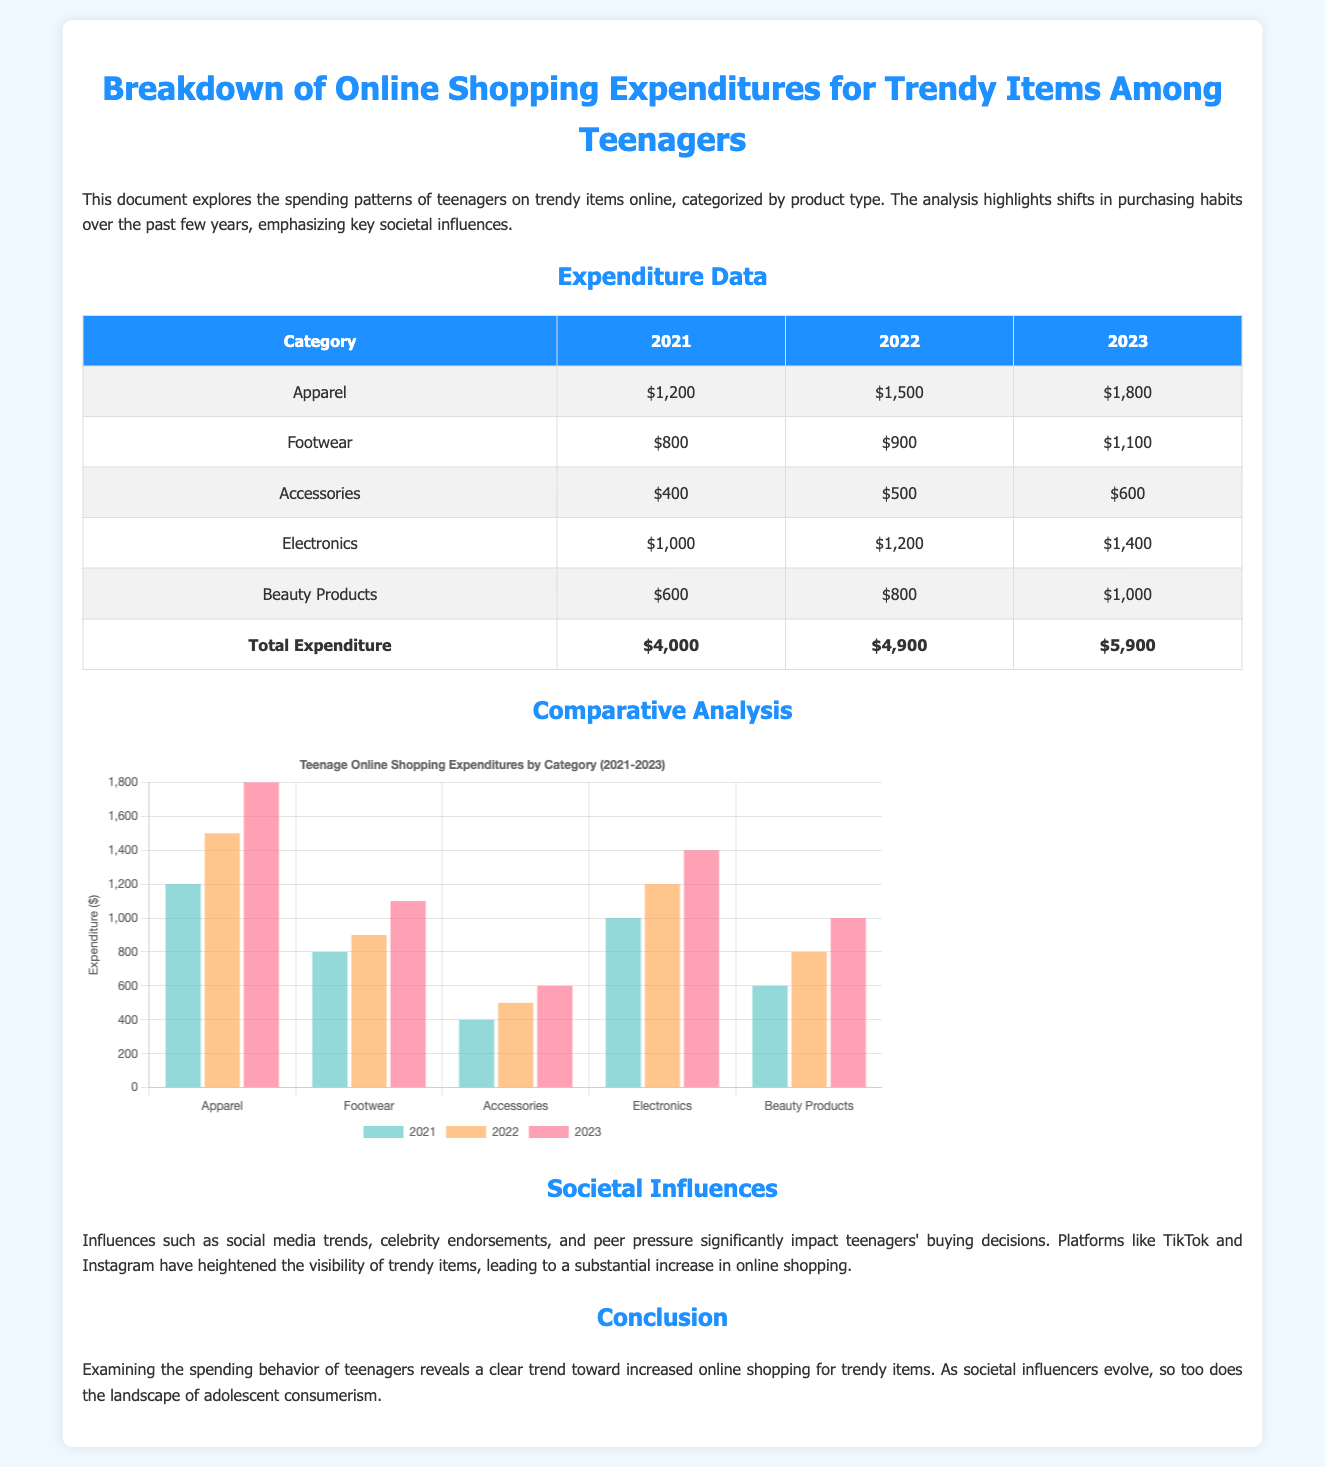What is the total expenditure in 2023? The total expenditure for 2023 is shown in the last row of the table, which sums up all categories for that year.
Answer: $5,900 Which product category had the highest expenditure in 2022? By comparing the expenditure data for 2022 across all categories, Apparel has the highest amount listed.
Answer: Apparel What was the expenditure for Footwear in 2021? The table indicates the expenditure for Footwear in 2021 is specifically stated under the corresponding year.
Answer: $800 What is the name of the chart illustrating teenage shopping expenditures? The title of the chart provided under the "Comparative Analysis" section describes the contents.
Answer: Teenage Online Shopping Expenditures by Category (2021-2023) How much did teenagers spend on Electronics in 2023? The specific expenditure amount for Electronics in 2023 is found in the relevant row of the table.
Answer: $1,400 What societal influences are mentioned that affect teenagers' buying decisions? The document explains specific influences observed related to teenage shopping behaviors, plugged into the text discussing societal impacts.
Answer: Social media trends, celebrity endorsements, and peer pressure What trend in online shopping expenditures is observed from 2021 to 2023? The document provides a general analysis of the expenditure data demonstrating the increase in online shopping expenditures.
Answer: Increased expenditure How much did teenagers spend on Beauty Products in 2022? The amount spent specifically on Beauty Products for the year 2022 is listed in the data table.
Answer: $800 What type of document is this? The overall format and content suggest the nature of the document as it shows data analysis and findings related to shopping expenditures.
Answer: Transaction document 